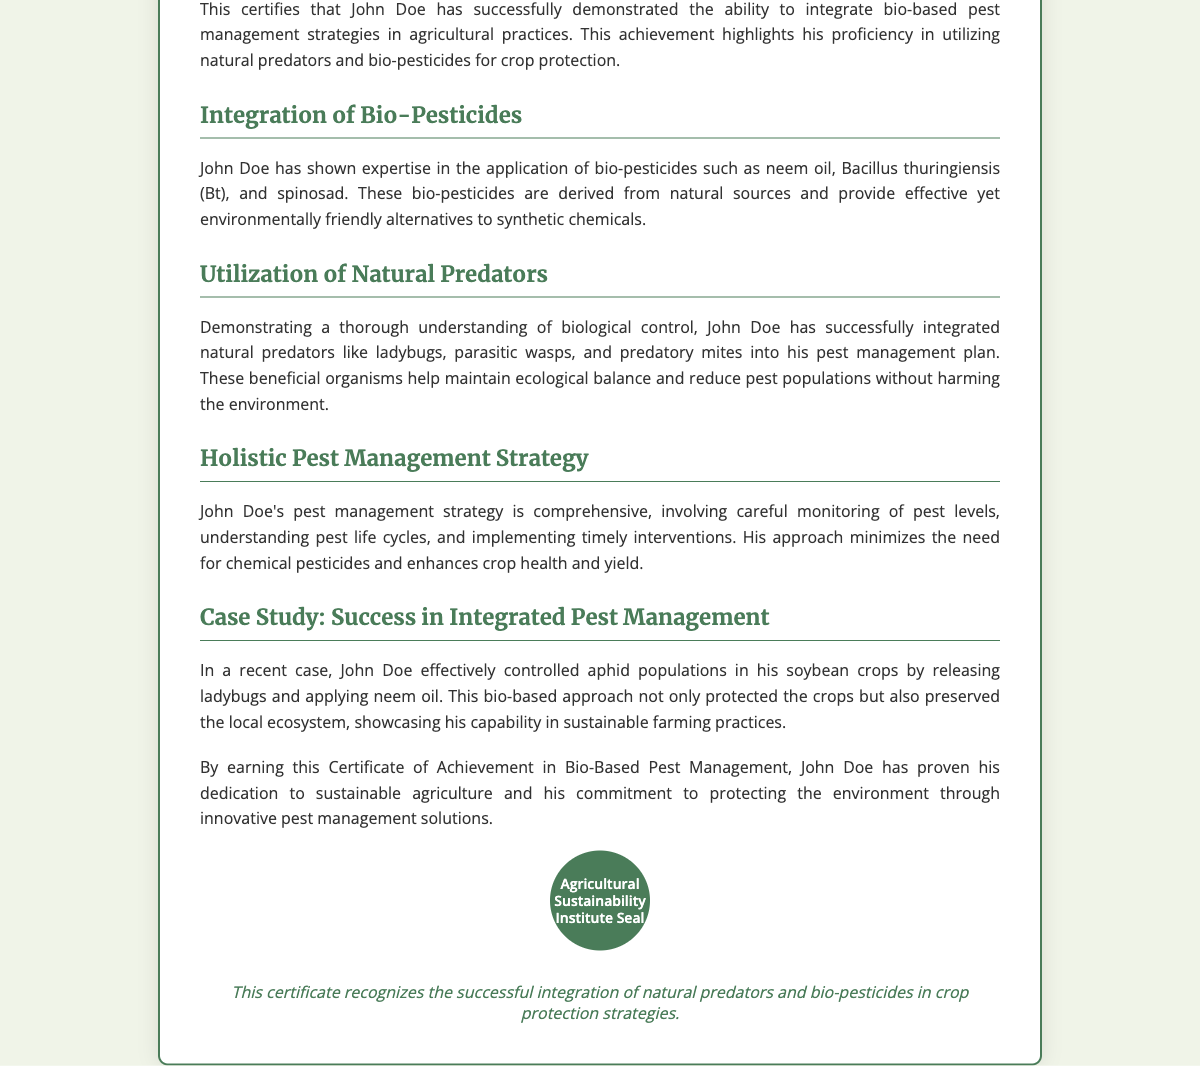What is the title of the certificate? The title of the certificate is prominently displayed at the top of the document, indicating the achievement recognized.
Answer: Certificate of Achievement in Bio-Based Pest Management Who is the recipient of the certificate? The recipient's name is clearly indicated below the title in bold, showcasing who earned the certificate.
Answer: John Doe What date was the certificate issued? The issuance date is specified in italics, providing a clear record of when the achievement was recognized.
Answer: October 20, 2023 Which organization issued the certificate? The issuing body's name is mentioned below the date, identifying the organization responsible for the certification.
Answer: Agricultural Sustainability Institute What types of bio-pesticides are mentioned? The document lists specific bio-pesticides as part of the recipient's expertise, highlighting the focus of the achievement.
Answer: neem oil, Bacillus thuringiensis (Bt), spinosad What natural predators are included in the pest management plan? The document outlines the types of beneficial organisms integrated into the recipient's pest management strategies.
Answer: ladybugs, parasitic wasps, predatory mites What was the case study mentioned related to? The case study illustrates a practical application of the recipient's strategies in managing specific pests effectively.
Answer: aphid populations in soybean crops What did John Doe's pest management strategy minimize the need for? The content emphasizes aspects of the recipient's strategy that reduce reliance on harmful substances.
Answer: chemical pesticides What does this certificate recognize overall? The footer provides a concise summary of the main focus of the achievement recognized by the certificate.
Answer: successful integration of natural predators and bio-pesticides in crop protection strategies 